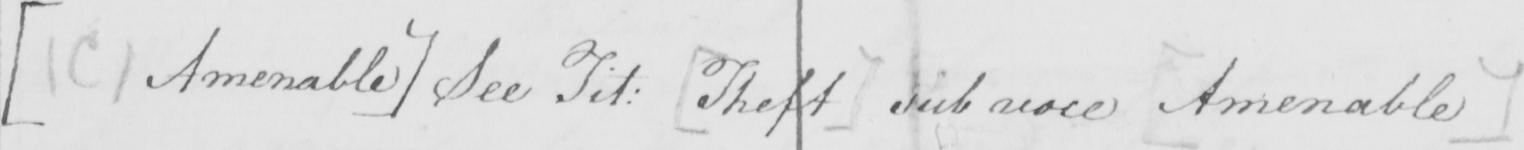What is written in this line of handwriting? [  ( C )  Amenable ]  See Tit :   [ Theft ]  sub voce  [ Amenable ] 